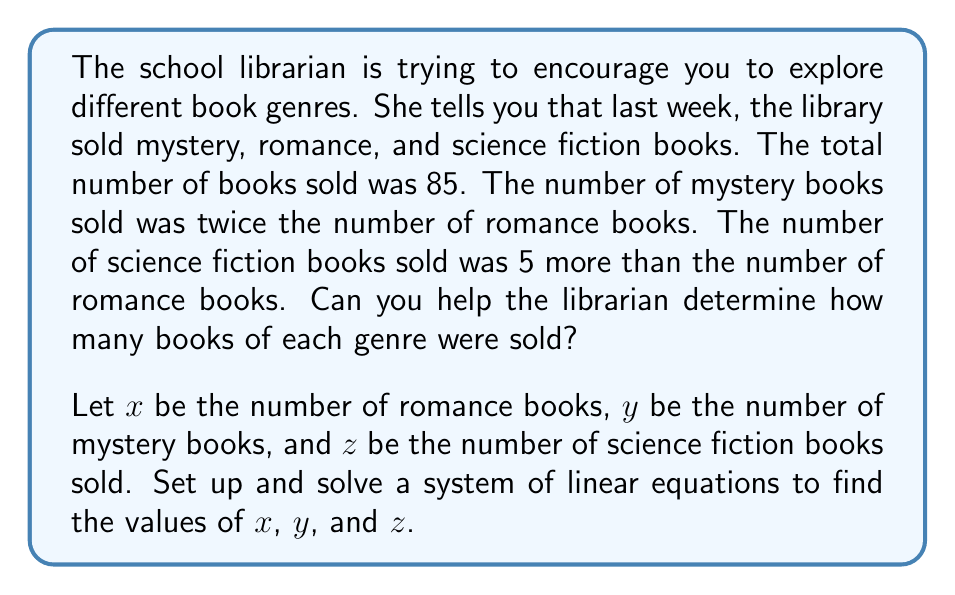Could you help me with this problem? Let's approach this step-by-step:

1) First, we'll set up our system of equations based on the given information:

   $$\begin{align}
   x + y + z &= 85 \tag{1} \\
   y &= 2x \tag{2} \\
   z &= x + 5 \tag{3}
   \end{align}$$

2) We can substitute equations (2) and (3) into equation (1):

   $$x + 2x + (x + 5) = 85$$

3) Simplify:

   $$4x + 5 = 85$$

4) Subtract 5 from both sides:

   $$4x = 80$$

5) Divide both sides by 4:

   $$x = 20$$

6) Now that we know $x$, we can find $y$ and $z$ using equations (2) and (3):

   $y = 2x = 2(20) = 40$
   $z = x + 5 = 20 + 5 = 25$

7) Let's verify our solution by plugging these values back into equation (1):

   $$20 + 40 + 25 = 85$$

   This checks out, so our solution is correct.
Answer: Romance books (x): 20
Mystery books (y): 40
Science fiction books (z): 25 